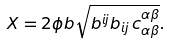Convert formula to latex. <formula><loc_0><loc_0><loc_500><loc_500>X = 2 \phi b \sqrt { b ^ { i j } b _ { i j } \, c ^ { \alpha \beta } _ { \alpha \beta } } .</formula> 